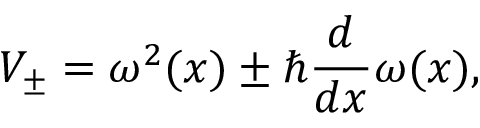Convert formula to latex. <formula><loc_0><loc_0><loc_500><loc_500>V _ { \pm } = \omega ^ { 2 } ( x ) \pm \hbar { } d } { d x } \omega ( x ) ,</formula> 